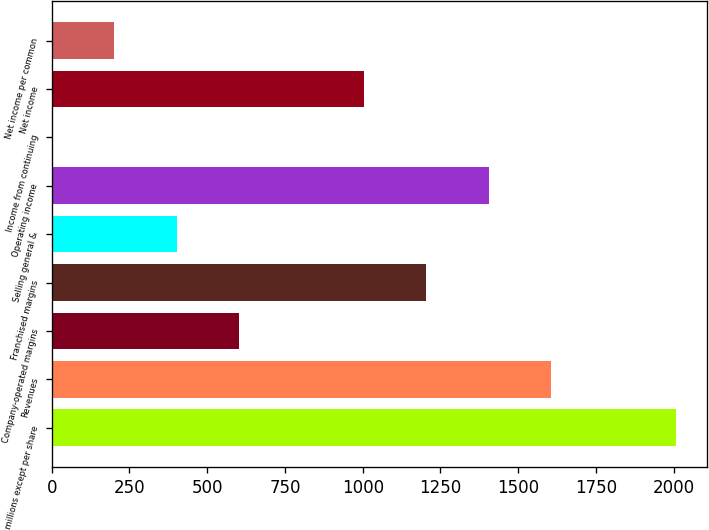Convert chart to OTSL. <chart><loc_0><loc_0><loc_500><loc_500><bar_chart><fcel>In millions except per share<fcel>Revenues<fcel>Company-operated margins<fcel>Franchised margins<fcel>Selling general &<fcel>Operating income<fcel>Income from continuing<fcel>Net income<fcel>Net income per common<nl><fcel>2007<fcel>1605.64<fcel>602.19<fcel>1204.26<fcel>401.5<fcel>1404.95<fcel>0.12<fcel>1003.57<fcel>200.81<nl></chart> 